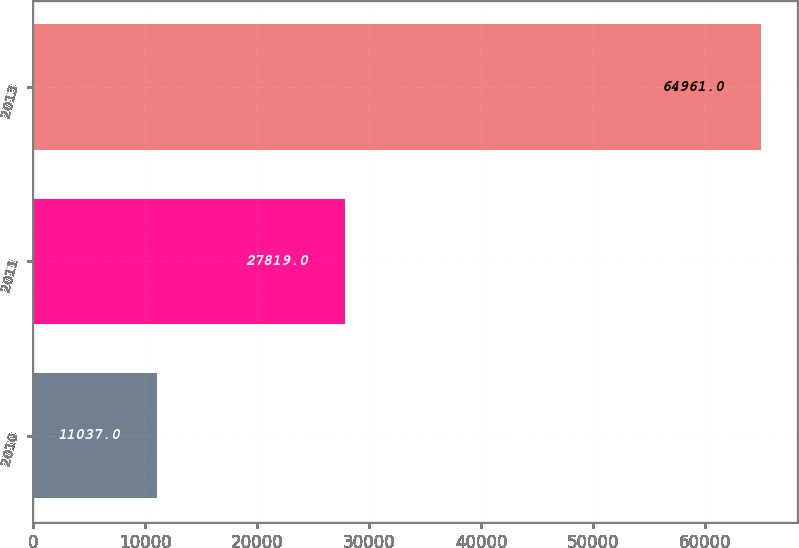Convert chart. <chart><loc_0><loc_0><loc_500><loc_500><bar_chart><fcel>2010<fcel>2011<fcel>2013<nl><fcel>11037<fcel>27819<fcel>64961<nl></chart> 